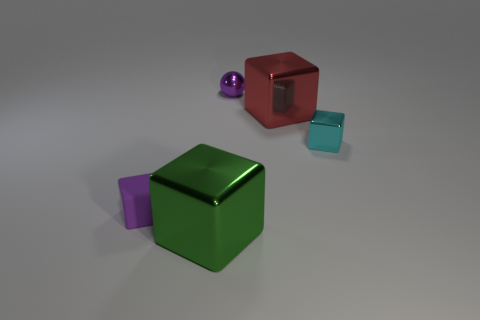Can you describe the lighting and shadows in this scene? The scene is lit from above as indicated by the shadows directly underneath the objects. The diffuse nature of the shadows suggests a soft and possibly large light source. The evenness of the lighting and lack of any harsh shadows or highlights indicate that the scene may be lit by ambient or studio lighting designed to reduce glare and provide uniform illumination. 